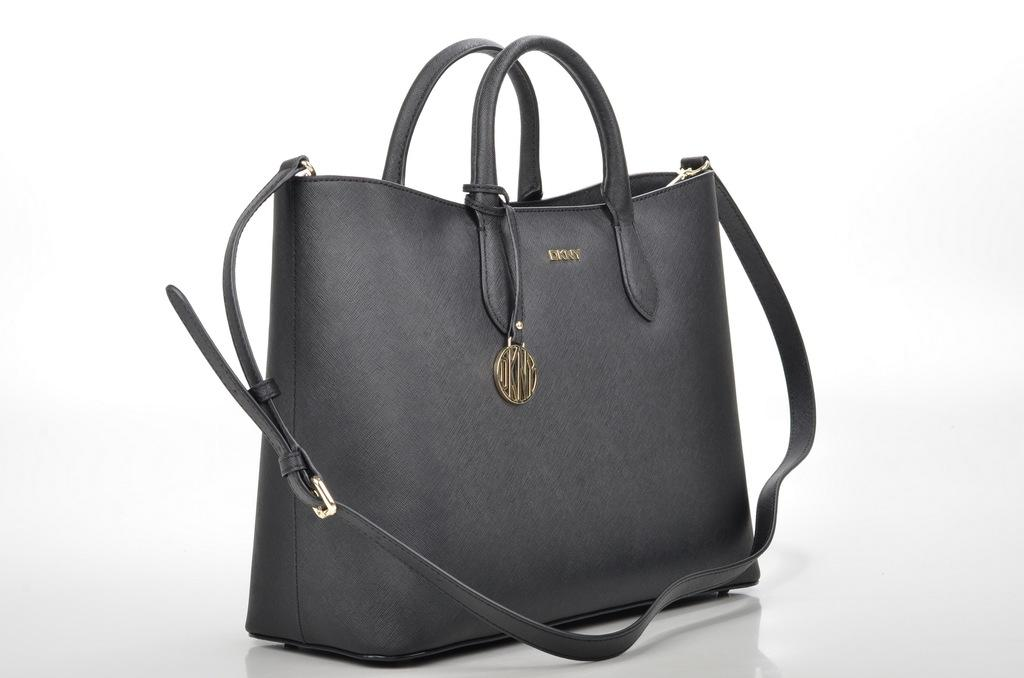What type of accessory is visible in the image? There is a black handbag in the image. Where is the handbag located? The handbag is on a table. What type of cannon is present in the image? There is no cannon present in the image. How many yards away is the handbag from the wall in the image? The image does not provide information about the distance between the handbag and any walls, nor is there a yardstick or any other means of measuring distance in the image. 